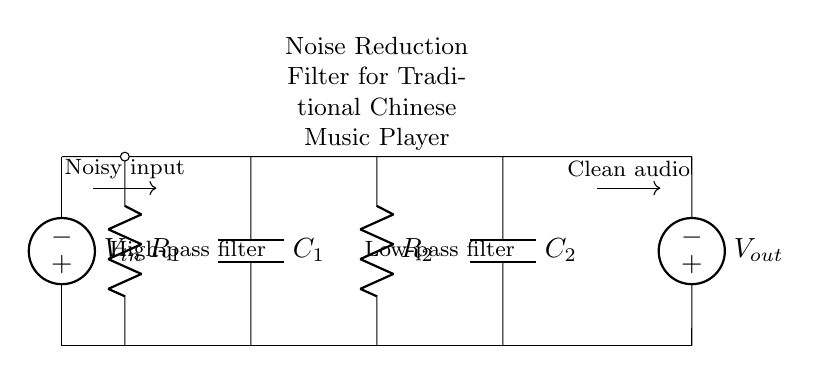What is the type of this circuit? This circuit is classified as a noise reduction filter designed with Resistor-Capacitor elements. The presence of resistors and capacitors suggests it is used for filtering purposes.
Answer: Noise reduction filter What are the components used in this circuit? The circuit contains two resistors (R1 and R2) and two capacitors (C1 and C2), which are fundamental elements in a Resistor-Capacitor circuit configuration.
Answer: Two resistors and two capacitors Which part of the circuit acts as the high-pass filter? The first branch with R1 and C1 functions as the high-pass filter, as high-frequency signals are allowed to pass while attenuating lower frequencies.
Answer: The first branch (R1 and C1) What is the function of C1 in this circuit? Capacitor C1 is used in conjunction with resistor R1 to block low-frequency signals and allow high-frequency components to pass, thus serving as a high-pass filter.
Answer: High-pass filter What will happen to noisy input signals? Noisy input signals will be filtered through the circuit, and the output will yield clean audio, emphasizing that the circuit is designed to reduce noise effectively.
Answer: Clean audio How do R2 and C2 function together? R2 and C2 form a low-pass filter, where they work together to allow low-frequency signals to pass while attenuating higher frequencies. This behavior is crucial for audio clarity in music playback.
Answer: Low-pass filter 